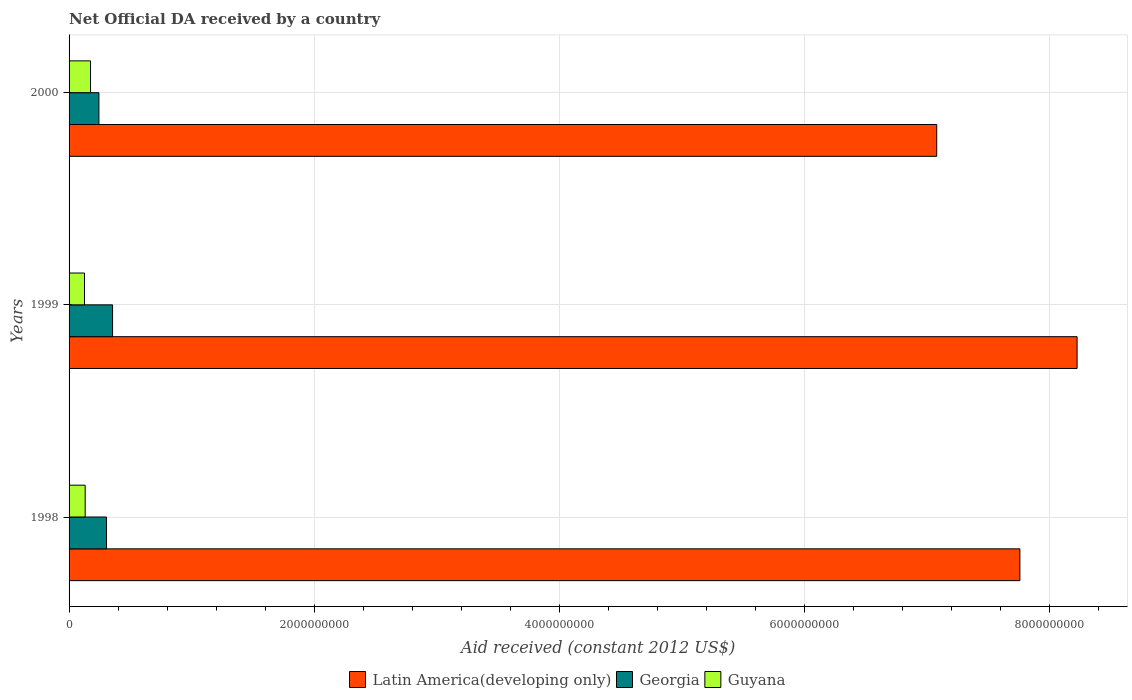How many groups of bars are there?
Make the answer very short. 3. Are the number of bars per tick equal to the number of legend labels?
Give a very brief answer. Yes. Are the number of bars on each tick of the Y-axis equal?
Give a very brief answer. Yes. How many bars are there on the 2nd tick from the top?
Make the answer very short. 3. What is the label of the 1st group of bars from the top?
Provide a short and direct response. 2000. What is the net official development assistance aid received in Georgia in 2000?
Offer a very short reply. 2.44e+08. Across all years, what is the maximum net official development assistance aid received in Guyana?
Ensure brevity in your answer.  1.75e+08. Across all years, what is the minimum net official development assistance aid received in Latin America(developing only)?
Provide a short and direct response. 7.08e+09. In which year was the net official development assistance aid received in Latin America(developing only) maximum?
Provide a succinct answer. 1999. What is the total net official development assistance aid received in Guyana in the graph?
Your answer should be compact. 4.32e+08. What is the difference between the net official development assistance aid received in Georgia in 1998 and that in 2000?
Keep it short and to the point. 6.21e+07. What is the difference between the net official development assistance aid received in Georgia in 2000 and the net official development assistance aid received in Guyana in 1998?
Your answer should be compact. 1.12e+08. What is the average net official development assistance aid received in Georgia per year?
Offer a very short reply. 3.01e+08. In the year 2000, what is the difference between the net official development assistance aid received in Guyana and net official development assistance aid received in Georgia?
Keep it short and to the point. -6.85e+07. In how many years, is the net official development assistance aid received in Guyana greater than 800000000 US$?
Provide a succinct answer. 0. What is the ratio of the net official development assistance aid received in Guyana in 1998 to that in 1999?
Your response must be concise. 1.05. Is the net official development assistance aid received in Guyana in 1998 less than that in 1999?
Provide a short and direct response. No. What is the difference between the highest and the second highest net official development assistance aid received in Guyana?
Give a very brief answer. 4.35e+07. What is the difference between the highest and the lowest net official development assistance aid received in Guyana?
Provide a short and direct response. 4.93e+07. In how many years, is the net official development assistance aid received in Georgia greater than the average net official development assistance aid received in Georgia taken over all years?
Your answer should be very brief. 2. What does the 3rd bar from the top in 2000 represents?
Your response must be concise. Latin America(developing only). What does the 1st bar from the bottom in 1999 represents?
Your answer should be very brief. Latin America(developing only). Are all the bars in the graph horizontal?
Your answer should be compact. Yes. How many years are there in the graph?
Your answer should be compact. 3. How are the legend labels stacked?
Make the answer very short. Horizontal. What is the title of the graph?
Your answer should be very brief. Net Official DA received by a country. Does "Singapore" appear as one of the legend labels in the graph?
Provide a succinct answer. No. What is the label or title of the X-axis?
Ensure brevity in your answer.  Aid received (constant 2012 US$). What is the label or title of the Y-axis?
Your answer should be compact. Years. What is the Aid received (constant 2012 US$) of Latin America(developing only) in 1998?
Your answer should be compact. 7.76e+09. What is the Aid received (constant 2012 US$) of Georgia in 1998?
Provide a succinct answer. 3.06e+08. What is the Aid received (constant 2012 US$) in Guyana in 1998?
Your answer should be compact. 1.32e+08. What is the Aid received (constant 2012 US$) in Latin America(developing only) in 1999?
Keep it short and to the point. 8.22e+09. What is the Aid received (constant 2012 US$) of Georgia in 1999?
Make the answer very short. 3.55e+08. What is the Aid received (constant 2012 US$) of Guyana in 1999?
Provide a succinct answer. 1.26e+08. What is the Aid received (constant 2012 US$) in Latin America(developing only) in 2000?
Provide a succinct answer. 7.08e+09. What is the Aid received (constant 2012 US$) of Georgia in 2000?
Provide a succinct answer. 2.44e+08. What is the Aid received (constant 2012 US$) of Guyana in 2000?
Your answer should be compact. 1.75e+08. Across all years, what is the maximum Aid received (constant 2012 US$) of Latin America(developing only)?
Your answer should be compact. 8.22e+09. Across all years, what is the maximum Aid received (constant 2012 US$) of Georgia?
Your answer should be very brief. 3.55e+08. Across all years, what is the maximum Aid received (constant 2012 US$) in Guyana?
Keep it short and to the point. 1.75e+08. Across all years, what is the minimum Aid received (constant 2012 US$) of Latin America(developing only)?
Provide a short and direct response. 7.08e+09. Across all years, what is the minimum Aid received (constant 2012 US$) in Georgia?
Your answer should be compact. 2.44e+08. Across all years, what is the minimum Aid received (constant 2012 US$) in Guyana?
Your answer should be very brief. 1.26e+08. What is the total Aid received (constant 2012 US$) of Latin America(developing only) in the graph?
Give a very brief answer. 2.31e+1. What is the total Aid received (constant 2012 US$) in Georgia in the graph?
Keep it short and to the point. 9.04e+08. What is the total Aid received (constant 2012 US$) in Guyana in the graph?
Give a very brief answer. 4.32e+08. What is the difference between the Aid received (constant 2012 US$) of Latin America(developing only) in 1998 and that in 1999?
Your answer should be compact. -4.67e+08. What is the difference between the Aid received (constant 2012 US$) of Georgia in 1998 and that in 1999?
Make the answer very short. -4.93e+07. What is the difference between the Aid received (constant 2012 US$) of Guyana in 1998 and that in 1999?
Offer a terse response. 5.84e+06. What is the difference between the Aid received (constant 2012 US$) in Latin America(developing only) in 1998 and that in 2000?
Offer a very short reply. 6.78e+08. What is the difference between the Aid received (constant 2012 US$) in Georgia in 1998 and that in 2000?
Keep it short and to the point. 6.21e+07. What is the difference between the Aid received (constant 2012 US$) of Guyana in 1998 and that in 2000?
Give a very brief answer. -4.35e+07. What is the difference between the Aid received (constant 2012 US$) in Latin America(developing only) in 1999 and that in 2000?
Make the answer very short. 1.15e+09. What is the difference between the Aid received (constant 2012 US$) in Georgia in 1999 and that in 2000?
Offer a terse response. 1.11e+08. What is the difference between the Aid received (constant 2012 US$) in Guyana in 1999 and that in 2000?
Provide a succinct answer. -4.93e+07. What is the difference between the Aid received (constant 2012 US$) of Latin America(developing only) in 1998 and the Aid received (constant 2012 US$) of Georgia in 1999?
Your answer should be compact. 7.40e+09. What is the difference between the Aid received (constant 2012 US$) of Latin America(developing only) in 1998 and the Aid received (constant 2012 US$) of Guyana in 1999?
Ensure brevity in your answer.  7.63e+09. What is the difference between the Aid received (constant 2012 US$) in Georgia in 1998 and the Aid received (constant 2012 US$) in Guyana in 1999?
Ensure brevity in your answer.  1.80e+08. What is the difference between the Aid received (constant 2012 US$) in Latin America(developing only) in 1998 and the Aid received (constant 2012 US$) in Georgia in 2000?
Give a very brief answer. 7.51e+09. What is the difference between the Aid received (constant 2012 US$) in Latin America(developing only) in 1998 and the Aid received (constant 2012 US$) in Guyana in 2000?
Give a very brief answer. 7.58e+09. What is the difference between the Aid received (constant 2012 US$) in Georgia in 1998 and the Aid received (constant 2012 US$) in Guyana in 2000?
Provide a short and direct response. 1.31e+08. What is the difference between the Aid received (constant 2012 US$) of Latin America(developing only) in 1999 and the Aid received (constant 2012 US$) of Georgia in 2000?
Offer a terse response. 7.98e+09. What is the difference between the Aid received (constant 2012 US$) in Latin America(developing only) in 1999 and the Aid received (constant 2012 US$) in Guyana in 2000?
Provide a succinct answer. 8.05e+09. What is the difference between the Aid received (constant 2012 US$) in Georgia in 1999 and the Aid received (constant 2012 US$) in Guyana in 2000?
Make the answer very short. 1.80e+08. What is the average Aid received (constant 2012 US$) of Latin America(developing only) per year?
Give a very brief answer. 7.69e+09. What is the average Aid received (constant 2012 US$) in Georgia per year?
Provide a short and direct response. 3.01e+08. What is the average Aid received (constant 2012 US$) of Guyana per year?
Your response must be concise. 1.44e+08. In the year 1998, what is the difference between the Aid received (constant 2012 US$) of Latin America(developing only) and Aid received (constant 2012 US$) of Georgia?
Provide a short and direct response. 7.45e+09. In the year 1998, what is the difference between the Aid received (constant 2012 US$) in Latin America(developing only) and Aid received (constant 2012 US$) in Guyana?
Ensure brevity in your answer.  7.63e+09. In the year 1998, what is the difference between the Aid received (constant 2012 US$) of Georgia and Aid received (constant 2012 US$) of Guyana?
Your response must be concise. 1.74e+08. In the year 1999, what is the difference between the Aid received (constant 2012 US$) in Latin America(developing only) and Aid received (constant 2012 US$) in Georgia?
Provide a succinct answer. 7.87e+09. In the year 1999, what is the difference between the Aid received (constant 2012 US$) of Latin America(developing only) and Aid received (constant 2012 US$) of Guyana?
Provide a succinct answer. 8.10e+09. In the year 1999, what is the difference between the Aid received (constant 2012 US$) of Georgia and Aid received (constant 2012 US$) of Guyana?
Your response must be concise. 2.29e+08. In the year 2000, what is the difference between the Aid received (constant 2012 US$) of Latin America(developing only) and Aid received (constant 2012 US$) of Georgia?
Give a very brief answer. 6.84e+09. In the year 2000, what is the difference between the Aid received (constant 2012 US$) in Latin America(developing only) and Aid received (constant 2012 US$) in Guyana?
Your response must be concise. 6.90e+09. In the year 2000, what is the difference between the Aid received (constant 2012 US$) of Georgia and Aid received (constant 2012 US$) of Guyana?
Ensure brevity in your answer.  6.85e+07. What is the ratio of the Aid received (constant 2012 US$) of Latin America(developing only) in 1998 to that in 1999?
Offer a terse response. 0.94. What is the ratio of the Aid received (constant 2012 US$) of Georgia in 1998 to that in 1999?
Provide a succinct answer. 0.86. What is the ratio of the Aid received (constant 2012 US$) in Guyana in 1998 to that in 1999?
Keep it short and to the point. 1.05. What is the ratio of the Aid received (constant 2012 US$) of Latin America(developing only) in 1998 to that in 2000?
Offer a very short reply. 1.1. What is the ratio of the Aid received (constant 2012 US$) of Georgia in 1998 to that in 2000?
Provide a succinct answer. 1.26. What is the ratio of the Aid received (constant 2012 US$) of Guyana in 1998 to that in 2000?
Your response must be concise. 0.75. What is the ratio of the Aid received (constant 2012 US$) of Latin America(developing only) in 1999 to that in 2000?
Provide a short and direct response. 1.16. What is the ratio of the Aid received (constant 2012 US$) of Georgia in 1999 to that in 2000?
Provide a succinct answer. 1.46. What is the ratio of the Aid received (constant 2012 US$) of Guyana in 1999 to that in 2000?
Ensure brevity in your answer.  0.72. What is the difference between the highest and the second highest Aid received (constant 2012 US$) of Latin America(developing only)?
Give a very brief answer. 4.67e+08. What is the difference between the highest and the second highest Aid received (constant 2012 US$) in Georgia?
Make the answer very short. 4.93e+07. What is the difference between the highest and the second highest Aid received (constant 2012 US$) in Guyana?
Give a very brief answer. 4.35e+07. What is the difference between the highest and the lowest Aid received (constant 2012 US$) in Latin America(developing only)?
Make the answer very short. 1.15e+09. What is the difference between the highest and the lowest Aid received (constant 2012 US$) of Georgia?
Your answer should be compact. 1.11e+08. What is the difference between the highest and the lowest Aid received (constant 2012 US$) of Guyana?
Provide a short and direct response. 4.93e+07. 